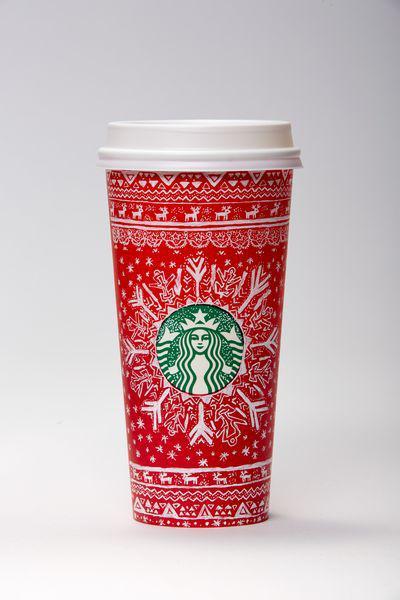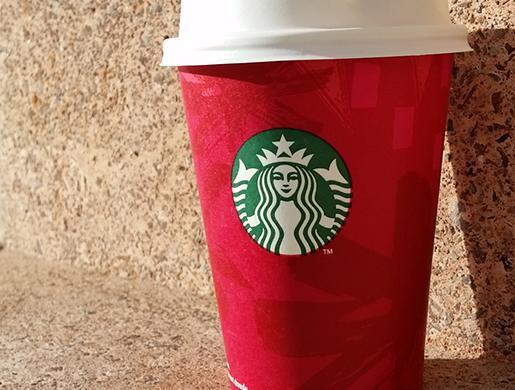The first image is the image on the left, the second image is the image on the right. Analyze the images presented: Is the assertion "There are two cups total." valid? Answer yes or no. Yes. The first image is the image on the left, the second image is the image on the right. For the images shown, is this caption "There is a total of two red coffee cups." true? Answer yes or no. Yes. 